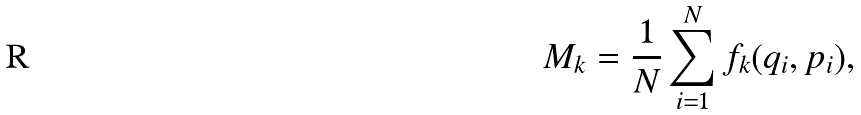<formula> <loc_0><loc_0><loc_500><loc_500>M _ { k } = \frac { 1 } { N } \sum _ { i = 1 } ^ { N } f _ { k } ( q _ { i } , p _ { i } ) ,</formula> 